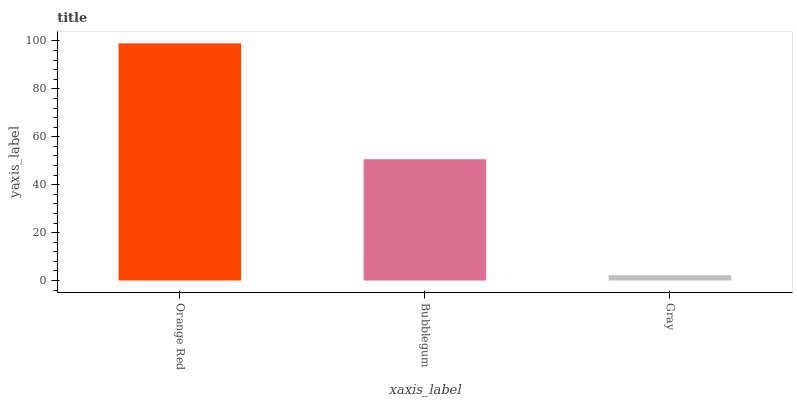Is Gray the minimum?
Answer yes or no. Yes. Is Orange Red the maximum?
Answer yes or no. Yes. Is Bubblegum the minimum?
Answer yes or no. No. Is Bubblegum the maximum?
Answer yes or no. No. Is Orange Red greater than Bubblegum?
Answer yes or no. Yes. Is Bubblegum less than Orange Red?
Answer yes or no. Yes. Is Bubblegum greater than Orange Red?
Answer yes or no. No. Is Orange Red less than Bubblegum?
Answer yes or no. No. Is Bubblegum the high median?
Answer yes or no. Yes. Is Bubblegum the low median?
Answer yes or no. Yes. Is Gray the high median?
Answer yes or no. No. Is Orange Red the low median?
Answer yes or no. No. 